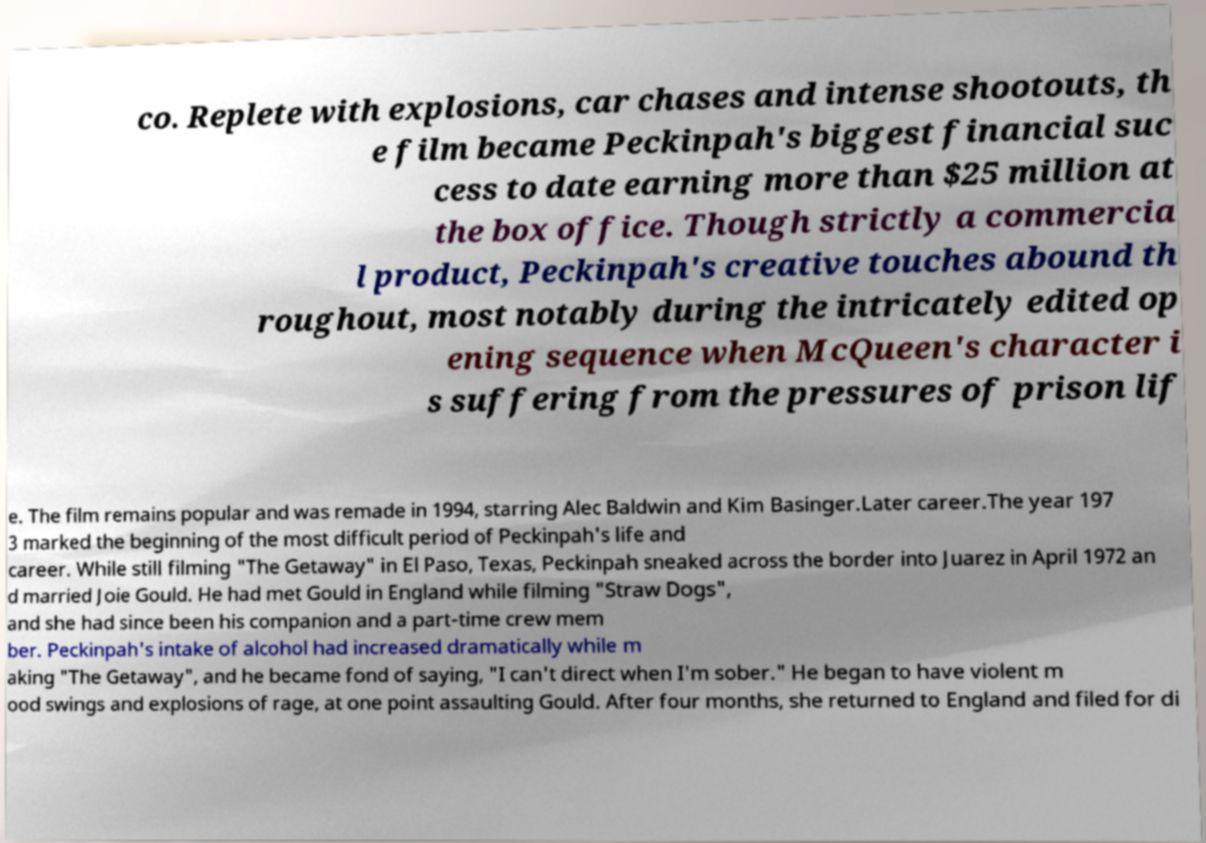I need the written content from this picture converted into text. Can you do that? co. Replete with explosions, car chases and intense shootouts, th e film became Peckinpah's biggest financial suc cess to date earning more than $25 million at the box office. Though strictly a commercia l product, Peckinpah's creative touches abound th roughout, most notably during the intricately edited op ening sequence when McQueen's character i s suffering from the pressures of prison lif e. The film remains popular and was remade in 1994, starring Alec Baldwin and Kim Basinger.Later career.The year 197 3 marked the beginning of the most difficult period of Peckinpah's life and career. While still filming "The Getaway" in El Paso, Texas, Peckinpah sneaked across the border into Juarez in April 1972 an d married Joie Gould. He had met Gould in England while filming "Straw Dogs", and she had since been his companion and a part-time crew mem ber. Peckinpah's intake of alcohol had increased dramatically while m aking "The Getaway", and he became fond of saying, "I can't direct when I'm sober." He began to have violent m ood swings and explosions of rage, at one point assaulting Gould. After four months, she returned to England and filed for di 